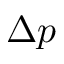<formula> <loc_0><loc_0><loc_500><loc_500>\Delta p</formula> 